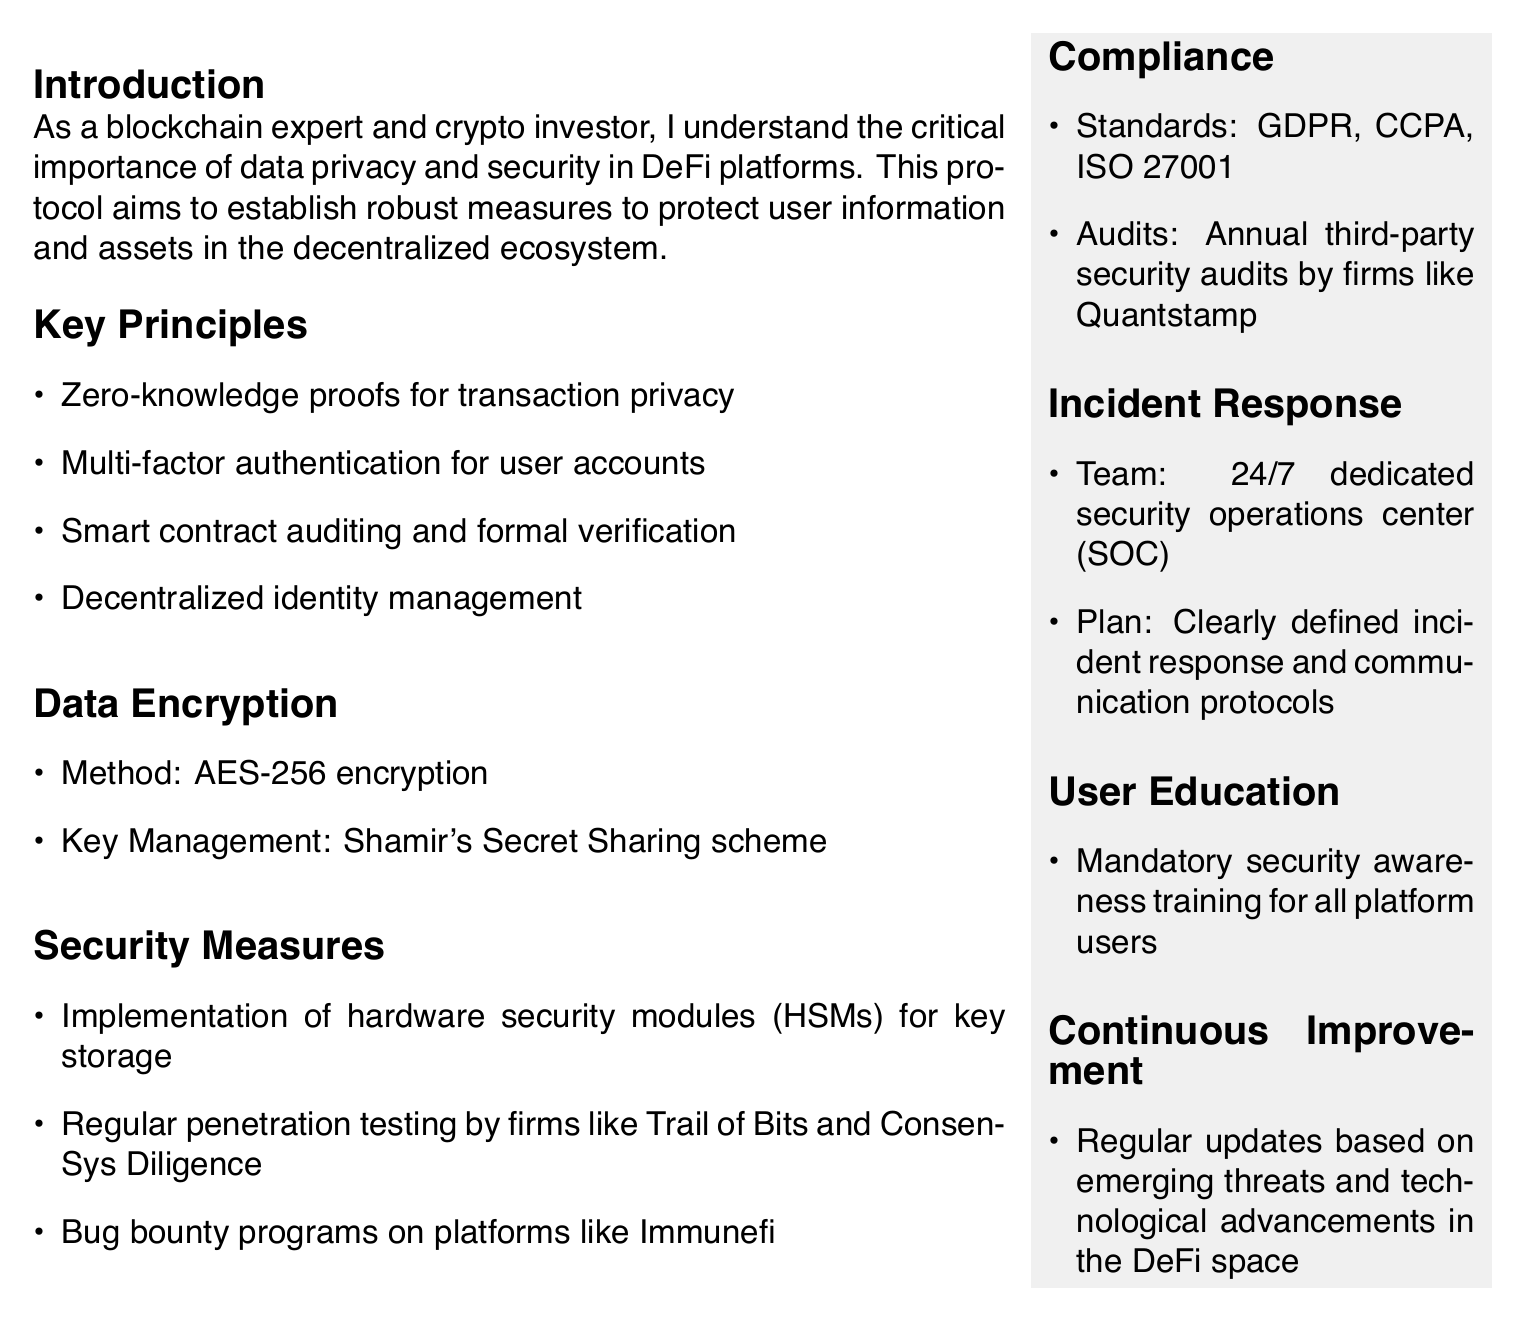what is the encryption method used in the document? The encryption method specified in the document is AES-256.
Answer: AES-256 what are the standards mentioned for compliance? The standards listed for compliance include GDPR, CCPA, and ISO 27001.
Answer: GDPR, CCPA, ISO 27001 what type of authentication is required for user accounts? The document specifies multi-factor authentication for user accounts.
Answer: multi-factor authentication what is the purpose of Shamir's Secret Sharing scheme? Shamir's Secret Sharing scheme is used for key management in the encryption process.
Answer: key management how often are third-party security audits conducted? The document states that third-party security audits are conducted annually.
Answer: Annual what is the main objective of the incident response team? The incident response team's objective includes defining incident response and communication protocols.
Answer: clearly defined incident response and communication protocols who conducts regular penetration testing? Regular penetration testing is conducted by firms like Trail of Bits and ConsenSys Diligence.
Answer: Trail of Bits and ConsenSys Diligence what does user education include? User education includes mandatory security awareness training for all platform users.
Answer: mandatory security awareness training what is emphasized for continuous improvement? The document emphasizes regular updates based on emerging threats and technological advancements.
Answer: regular updates based on emerging threats and technological advancements 